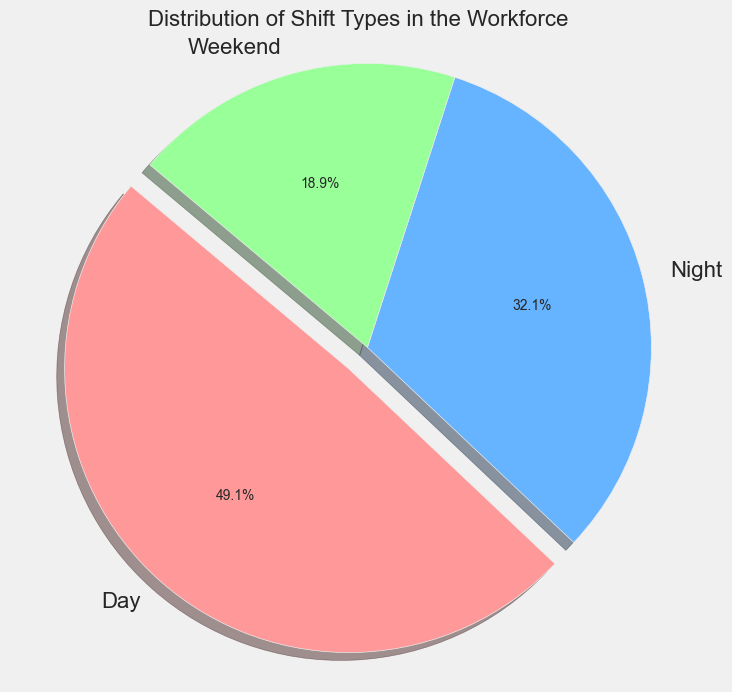What is the most common shift type in the workforce? By looking at the pie chart, the shift type with the largest slice represents the most common shift type. In this case, the 'Day' shift has the largest slice.
Answer: Day What percentage of the workforce works night shifts? The slice representing the 'Night' shift is labeled with the percentage. According to the pie chart, the 'Night' shift makes up 30.0% of the workforce.
Answer: 30.0% Combine the percentages of night and weekend shifts. What is the total? Adding the percentages for 'Night' shifts (30.0%) and 'Weekend' shifts (20.0%) provides the total. 30.0% + 20.0% = 50.0%.
Answer: 50.0% Which shift type has the smallest percentage of workers? The smallest slice of the pie chart corresponds to the shift type with the smallest percentage. Here, the 'Weekend' shift is the smallest.
Answer: Weekend How much larger is the day shift percentage compared to the night shift percentage? Subtract the percentage of 'Night' shifts (30.0%) from the percentage of 'Day' shifts (46.2%). 46.2% - 30.0% = 16.2%.
Answer: 16.2% What color represents weekend shifts in the pie chart? By observing the colors in the legend associated with each shift type, we can identify that 'Weekend' shifts are represented by green.
Answer: Green If 15% of workers' shifts were reallocated from day to night, what would be the new percentage for each shift type? Calculate new percentages:
Day: 46.2% - 15% = 31.2%
Night: 30.0% + 15% = 45.0%
Weekend: 20.0% (unchanged)
Answer: Day: 31.2%, Night: 45.0%, Weekend: 20.0% Which two shift types together make up more than half of the pie chart? Add the percentages of different combinations until one totals more than 50%. 'Day' (46.2%) and 'Night' (30.0%) together make up 76.2%, which is greater than 50%.
Answer: Day and Night If the workforce total is 875 people, how many people work weekend shifts? Calculate the number using the percentage for 'Weekend' shifts: 20.0% of 875 people. 0.20 * 875 = 175 people.
Answer: 175 Discuss the general trend or distribution of shifts among the workforce based on the pie chart. By looking at the sizes of the slices, 'Day' shifts are the most common, followed by 'Night', and 'Weekend' being the least common. This indicates a higher preference or requirement for day shifts.
Answer: Day shifts are the most common, Weekend shifts are the least common 